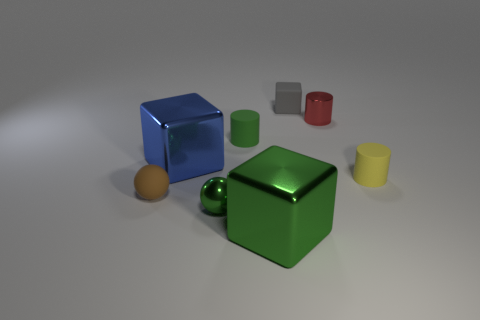Subtract all tiny green matte cylinders. How many cylinders are left? 2 Add 2 tiny green rubber things. How many objects exist? 10 Subtract all green balls. How many balls are left? 1 Subtract 2 cylinders. How many cylinders are left? 1 Subtract all red spheres. How many blue cubes are left? 1 Subtract 0 cyan cubes. How many objects are left? 8 Subtract all cylinders. How many objects are left? 5 Subtract all gray cubes. Subtract all red spheres. How many cubes are left? 2 Subtract all small purple matte balls. Subtract all large metallic cubes. How many objects are left? 6 Add 4 red metal cylinders. How many red metal cylinders are left? 5 